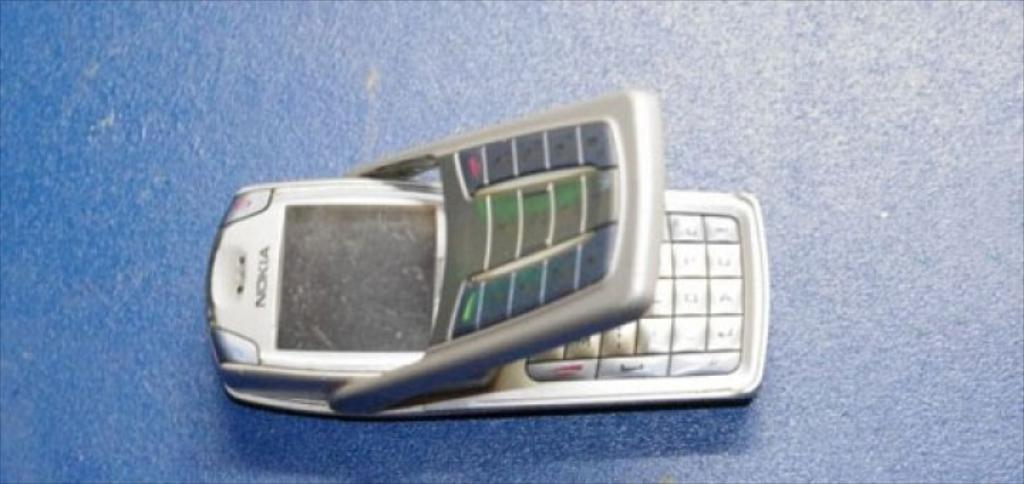<image>
Provide a brief description of the given image. A Nokia flip phone that is wedged open. 